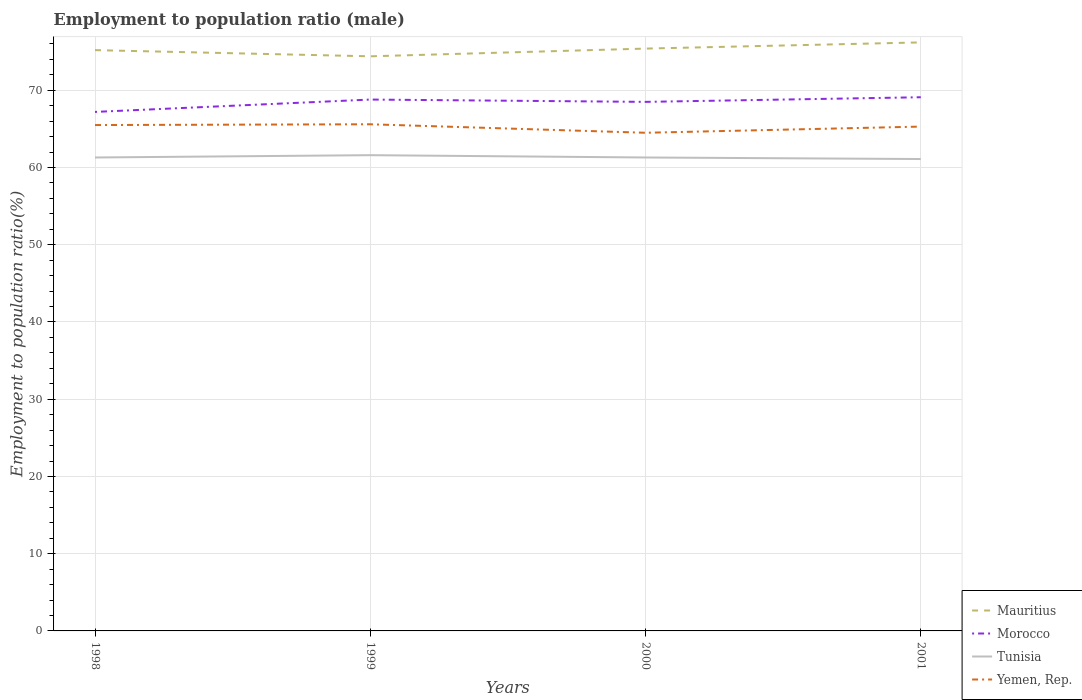Does the line corresponding to Yemen, Rep. intersect with the line corresponding to Tunisia?
Your answer should be very brief. No. Is the number of lines equal to the number of legend labels?
Provide a succinct answer. Yes. Across all years, what is the maximum employment to population ratio in Morocco?
Provide a short and direct response. 67.2. Is the employment to population ratio in Mauritius strictly greater than the employment to population ratio in Morocco over the years?
Provide a succinct answer. No. How many lines are there?
Your answer should be compact. 4. How many years are there in the graph?
Give a very brief answer. 4. What is the difference between two consecutive major ticks on the Y-axis?
Your answer should be very brief. 10. Are the values on the major ticks of Y-axis written in scientific E-notation?
Keep it short and to the point. No. Does the graph contain grids?
Your answer should be compact. Yes. How many legend labels are there?
Your answer should be very brief. 4. What is the title of the graph?
Provide a short and direct response. Employment to population ratio (male). What is the label or title of the Y-axis?
Ensure brevity in your answer.  Employment to population ratio(%). What is the Employment to population ratio(%) of Mauritius in 1998?
Your answer should be very brief. 75.2. What is the Employment to population ratio(%) in Morocco in 1998?
Ensure brevity in your answer.  67.2. What is the Employment to population ratio(%) in Tunisia in 1998?
Provide a short and direct response. 61.3. What is the Employment to population ratio(%) in Yemen, Rep. in 1998?
Keep it short and to the point. 65.5. What is the Employment to population ratio(%) in Mauritius in 1999?
Offer a very short reply. 74.4. What is the Employment to population ratio(%) in Morocco in 1999?
Provide a short and direct response. 68.8. What is the Employment to population ratio(%) in Tunisia in 1999?
Give a very brief answer. 61.6. What is the Employment to population ratio(%) in Yemen, Rep. in 1999?
Provide a succinct answer. 65.6. What is the Employment to population ratio(%) in Mauritius in 2000?
Your response must be concise. 75.4. What is the Employment to population ratio(%) of Morocco in 2000?
Your response must be concise. 68.5. What is the Employment to population ratio(%) in Tunisia in 2000?
Offer a very short reply. 61.3. What is the Employment to population ratio(%) of Yemen, Rep. in 2000?
Offer a terse response. 64.5. What is the Employment to population ratio(%) in Mauritius in 2001?
Make the answer very short. 76.2. What is the Employment to population ratio(%) in Morocco in 2001?
Your response must be concise. 69.1. What is the Employment to population ratio(%) of Tunisia in 2001?
Offer a terse response. 61.1. What is the Employment to population ratio(%) in Yemen, Rep. in 2001?
Offer a terse response. 65.3. Across all years, what is the maximum Employment to population ratio(%) in Mauritius?
Your answer should be very brief. 76.2. Across all years, what is the maximum Employment to population ratio(%) in Morocco?
Make the answer very short. 69.1. Across all years, what is the maximum Employment to population ratio(%) in Tunisia?
Make the answer very short. 61.6. Across all years, what is the maximum Employment to population ratio(%) in Yemen, Rep.?
Your response must be concise. 65.6. Across all years, what is the minimum Employment to population ratio(%) in Mauritius?
Keep it short and to the point. 74.4. Across all years, what is the minimum Employment to population ratio(%) in Morocco?
Keep it short and to the point. 67.2. Across all years, what is the minimum Employment to population ratio(%) of Tunisia?
Provide a short and direct response. 61.1. Across all years, what is the minimum Employment to population ratio(%) in Yemen, Rep.?
Make the answer very short. 64.5. What is the total Employment to population ratio(%) of Mauritius in the graph?
Offer a very short reply. 301.2. What is the total Employment to population ratio(%) of Morocco in the graph?
Provide a short and direct response. 273.6. What is the total Employment to population ratio(%) of Tunisia in the graph?
Offer a very short reply. 245.3. What is the total Employment to population ratio(%) in Yemen, Rep. in the graph?
Make the answer very short. 260.9. What is the difference between the Employment to population ratio(%) in Mauritius in 1998 and that in 1999?
Offer a terse response. 0.8. What is the difference between the Employment to population ratio(%) of Tunisia in 1998 and that in 1999?
Provide a succinct answer. -0.3. What is the difference between the Employment to population ratio(%) of Morocco in 1998 and that in 2000?
Provide a short and direct response. -1.3. What is the difference between the Employment to population ratio(%) of Mauritius in 1998 and that in 2001?
Your answer should be compact. -1. What is the difference between the Employment to population ratio(%) of Tunisia in 1998 and that in 2001?
Your response must be concise. 0.2. What is the difference between the Employment to population ratio(%) in Yemen, Rep. in 1998 and that in 2001?
Provide a short and direct response. 0.2. What is the difference between the Employment to population ratio(%) in Mauritius in 1999 and that in 2000?
Your response must be concise. -1. What is the difference between the Employment to population ratio(%) in Morocco in 1999 and that in 2000?
Offer a very short reply. 0.3. What is the difference between the Employment to population ratio(%) of Tunisia in 1999 and that in 2000?
Your answer should be very brief. 0.3. What is the difference between the Employment to population ratio(%) in Morocco in 1999 and that in 2001?
Offer a terse response. -0.3. What is the difference between the Employment to population ratio(%) of Yemen, Rep. in 1999 and that in 2001?
Offer a terse response. 0.3. What is the difference between the Employment to population ratio(%) in Yemen, Rep. in 2000 and that in 2001?
Provide a succinct answer. -0.8. What is the difference between the Employment to population ratio(%) of Mauritius in 1998 and the Employment to population ratio(%) of Yemen, Rep. in 1999?
Ensure brevity in your answer.  9.6. What is the difference between the Employment to population ratio(%) in Morocco in 1998 and the Employment to population ratio(%) in Tunisia in 1999?
Offer a very short reply. 5.6. What is the difference between the Employment to population ratio(%) in Morocco in 1998 and the Employment to population ratio(%) in Yemen, Rep. in 1999?
Keep it short and to the point. 1.6. What is the difference between the Employment to population ratio(%) of Tunisia in 1998 and the Employment to population ratio(%) of Yemen, Rep. in 1999?
Your response must be concise. -4.3. What is the difference between the Employment to population ratio(%) of Mauritius in 1998 and the Employment to population ratio(%) of Morocco in 2000?
Your answer should be very brief. 6.7. What is the difference between the Employment to population ratio(%) of Mauritius in 1998 and the Employment to population ratio(%) of Tunisia in 2000?
Provide a short and direct response. 13.9. What is the difference between the Employment to population ratio(%) in Morocco in 1998 and the Employment to population ratio(%) in Tunisia in 2000?
Make the answer very short. 5.9. What is the difference between the Employment to population ratio(%) in Tunisia in 1998 and the Employment to population ratio(%) in Yemen, Rep. in 2000?
Give a very brief answer. -3.2. What is the difference between the Employment to population ratio(%) of Mauritius in 1998 and the Employment to population ratio(%) of Morocco in 2001?
Make the answer very short. 6.1. What is the difference between the Employment to population ratio(%) in Mauritius in 1998 and the Employment to population ratio(%) in Tunisia in 2001?
Offer a very short reply. 14.1. What is the difference between the Employment to population ratio(%) of Mauritius in 1998 and the Employment to population ratio(%) of Yemen, Rep. in 2001?
Provide a succinct answer. 9.9. What is the difference between the Employment to population ratio(%) in Morocco in 1999 and the Employment to population ratio(%) in Yemen, Rep. in 2000?
Ensure brevity in your answer.  4.3. What is the difference between the Employment to population ratio(%) in Mauritius in 1999 and the Employment to population ratio(%) in Morocco in 2001?
Your answer should be very brief. 5.3. What is the difference between the Employment to population ratio(%) in Mauritius in 1999 and the Employment to population ratio(%) in Tunisia in 2001?
Your answer should be very brief. 13.3. What is the difference between the Employment to population ratio(%) in Mauritius in 2000 and the Employment to population ratio(%) in Tunisia in 2001?
Your answer should be very brief. 14.3. What is the difference between the Employment to population ratio(%) in Morocco in 2000 and the Employment to population ratio(%) in Yemen, Rep. in 2001?
Your response must be concise. 3.2. What is the difference between the Employment to population ratio(%) in Tunisia in 2000 and the Employment to population ratio(%) in Yemen, Rep. in 2001?
Provide a succinct answer. -4. What is the average Employment to population ratio(%) of Mauritius per year?
Your answer should be very brief. 75.3. What is the average Employment to population ratio(%) of Morocco per year?
Ensure brevity in your answer.  68.4. What is the average Employment to population ratio(%) of Tunisia per year?
Your answer should be very brief. 61.33. What is the average Employment to population ratio(%) of Yemen, Rep. per year?
Offer a very short reply. 65.22. In the year 1998, what is the difference between the Employment to population ratio(%) of Mauritius and Employment to population ratio(%) of Morocco?
Make the answer very short. 8. In the year 1998, what is the difference between the Employment to population ratio(%) of Mauritius and Employment to population ratio(%) of Tunisia?
Your response must be concise. 13.9. In the year 1998, what is the difference between the Employment to population ratio(%) of Tunisia and Employment to population ratio(%) of Yemen, Rep.?
Your response must be concise. -4.2. In the year 1999, what is the difference between the Employment to population ratio(%) of Mauritius and Employment to population ratio(%) of Morocco?
Your response must be concise. 5.6. In the year 1999, what is the difference between the Employment to population ratio(%) in Mauritius and Employment to population ratio(%) in Tunisia?
Offer a very short reply. 12.8. In the year 2000, what is the difference between the Employment to population ratio(%) in Mauritius and Employment to population ratio(%) in Morocco?
Offer a terse response. 6.9. In the year 2000, what is the difference between the Employment to population ratio(%) in Morocco and Employment to population ratio(%) in Tunisia?
Your answer should be very brief. 7.2. In the year 2000, what is the difference between the Employment to population ratio(%) in Tunisia and Employment to population ratio(%) in Yemen, Rep.?
Ensure brevity in your answer.  -3.2. In the year 2001, what is the difference between the Employment to population ratio(%) in Mauritius and Employment to population ratio(%) in Tunisia?
Keep it short and to the point. 15.1. In the year 2001, what is the difference between the Employment to population ratio(%) of Mauritius and Employment to population ratio(%) of Yemen, Rep.?
Make the answer very short. 10.9. What is the ratio of the Employment to population ratio(%) in Mauritius in 1998 to that in 1999?
Make the answer very short. 1.01. What is the ratio of the Employment to population ratio(%) in Morocco in 1998 to that in 1999?
Keep it short and to the point. 0.98. What is the ratio of the Employment to population ratio(%) in Tunisia in 1998 to that in 1999?
Ensure brevity in your answer.  1. What is the ratio of the Employment to population ratio(%) of Yemen, Rep. in 1998 to that in 1999?
Make the answer very short. 1. What is the ratio of the Employment to population ratio(%) in Yemen, Rep. in 1998 to that in 2000?
Ensure brevity in your answer.  1.02. What is the ratio of the Employment to population ratio(%) in Mauritius in 1998 to that in 2001?
Offer a very short reply. 0.99. What is the ratio of the Employment to population ratio(%) of Morocco in 1998 to that in 2001?
Offer a terse response. 0.97. What is the ratio of the Employment to population ratio(%) in Mauritius in 1999 to that in 2000?
Ensure brevity in your answer.  0.99. What is the ratio of the Employment to population ratio(%) of Morocco in 1999 to that in 2000?
Your answer should be compact. 1. What is the ratio of the Employment to population ratio(%) of Tunisia in 1999 to that in 2000?
Provide a short and direct response. 1. What is the ratio of the Employment to population ratio(%) of Yemen, Rep. in 1999 to that in 2000?
Your response must be concise. 1.02. What is the ratio of the Employment to population ratio(%) in Mauritius in 1999 to that in 2001?
Offer a very short reply. 0.98. What is the ratio of the Employment to population ratio(%) of Morocco in 1999 to that in 2001?
Give a very brief answer. 1. What is the ratio of the Employment to population ratio(%) of Tunisia in 1999 to that in 2001?
Offer a terse response. 1.01. What is the ratio of the Employment to population ratio(%) of Yemen, Rep. in 1999 to that in 2001?
Make the answer very short. 1. What is the ratio of the Employment to population ratio(%) in Mauritius in 2000 to that in 2001?
Keep it short and to the point. 0.99. What is the ratio of the Employment to population ratio(%) of Morocco in 2000 to that in 2001?
Make the answer very short. 0.99. What is the ratio of the Employment to population ratio(%) of Yemen, Rep. in 2000 to that in 2001?
Ensure brevity in your answer.  0.99. What is the difference between the highest and the second highest Employment to population ratio(%) of Mauritius?
Offer a terse response. 0.8. What is the difference between the highest and the second highest Employment to population ratio(%) in Morocco?
Give a very brief answer. 0.3. 